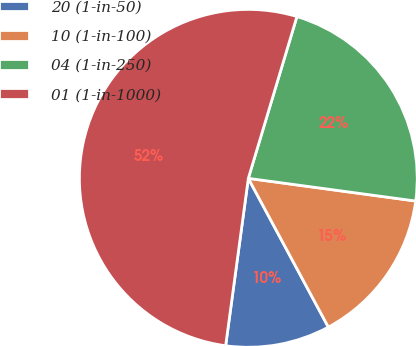Convert chart to OTSL. <chart><loc_0><loc_0><loc_500><loc_500><pie_chart><fcel>20 (1-in-50)<fcel>10 (1-in-100)<fcel>04 (1-in-250)<fcel>01 (1-in-1000)<nl><fcel>10.0%<fcel>15.0%<fcel>22.5%<fcel>52.5%<nl></chart> 